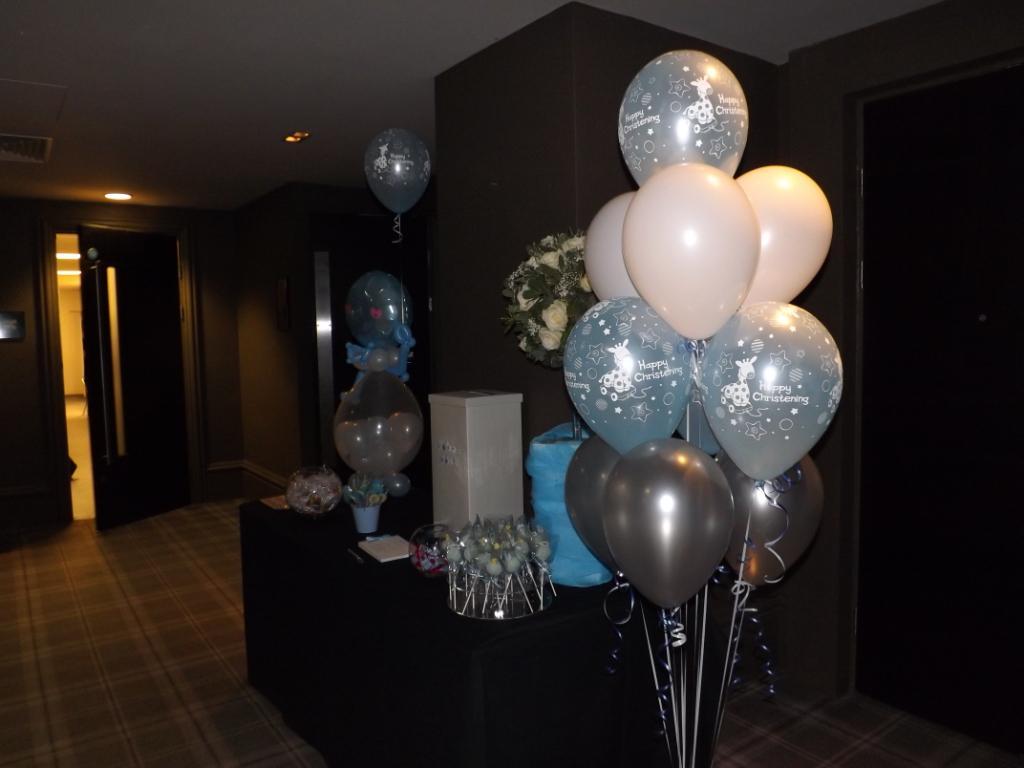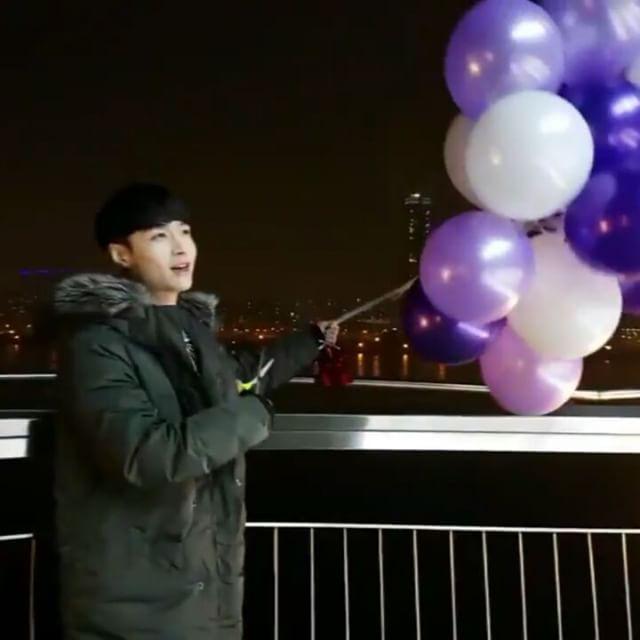The first image is the image on the left, the second image is the image on the right. Examine the images to the left and right. Is the description "One image shows exactly one human interacting with a single balloon in what could be a science demonstration, while the other image shows exactly three balloons." accurate? Answer yes or no. No. The first image is the image on the left, the second image is the image on the right. Given the left and right images, does the statement "The image on the right contains at least one blue balloon." hold true? Answer yes or no. No. 